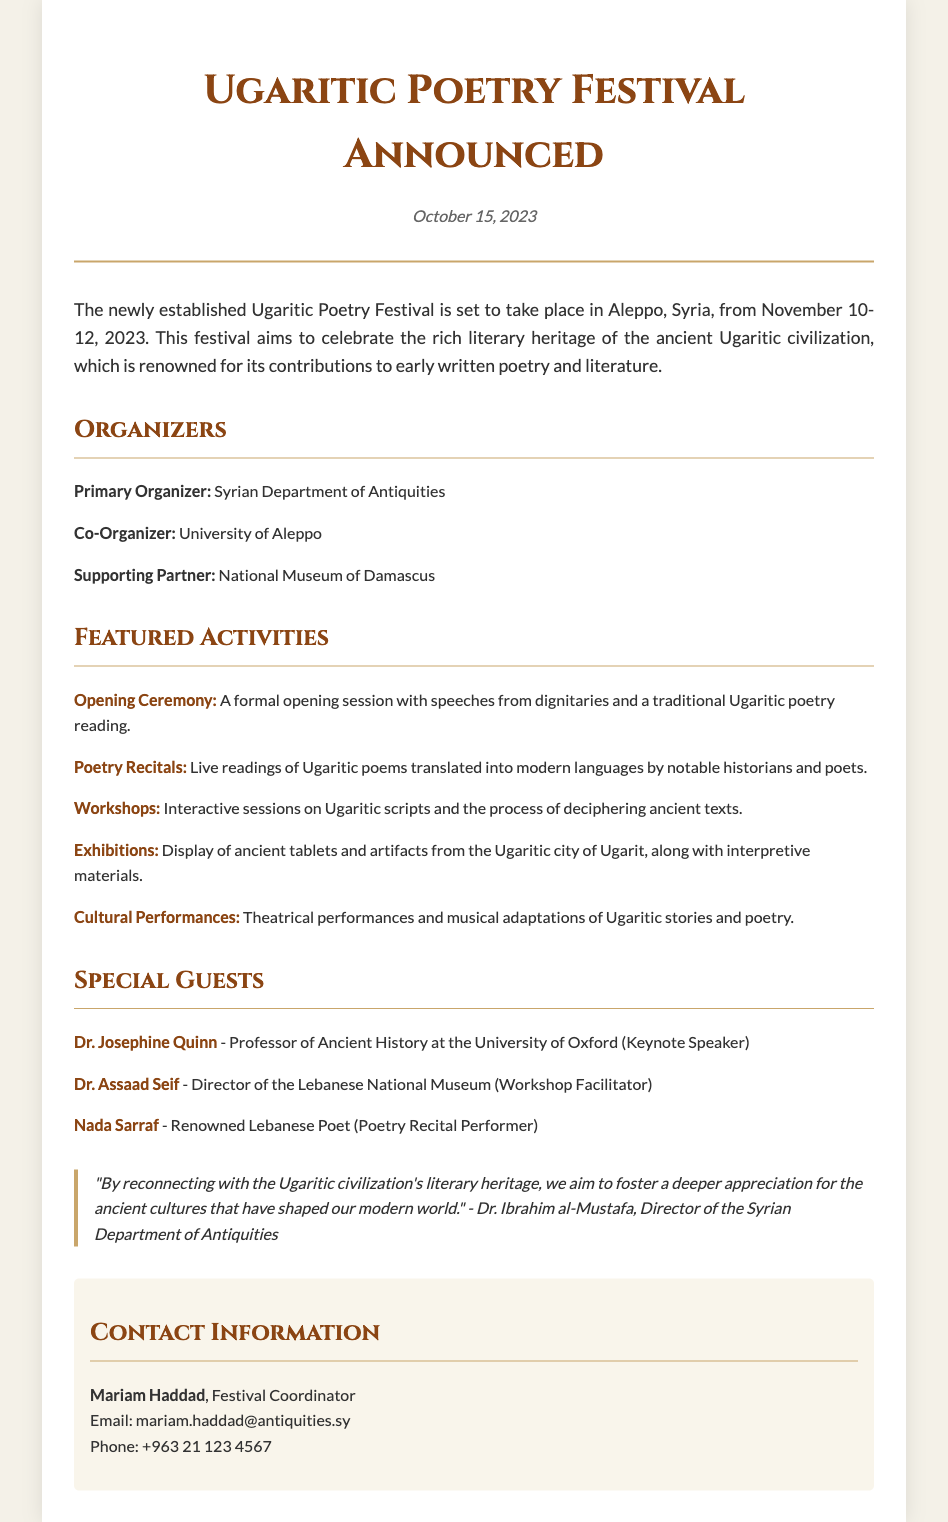What are the dates of the Ugaritic Poetry Festival? The festival will take place from November 10-12, 2023, as stated in the introduction.
Answer: November 10-12, 2023 Who is the primary organizer of the festival? The primary organizer listed in the document is the Syrian Department of Antiquities.
Answer: Syrian Department of Antiquities What type of activities will be featured at the festival? The document mentions that activities include Opening Ceremony, Poetry Recitals, Workshops, Exhibitions, and Cultural Performances.
Answer: Opening Ceremony, Poetry Recitals, Workshops, Exhibitions, Cultural Performances Who is the keynote speaker at the festival? The document specifies Dr. Josephine Quinn as the keynote speaker.
Answer: Dr. Josephine Quinn What is the purpose of the Ugaritic Poetry Festival? The festival aims to celebrate the rich literary heritage of the ancient Ugaritic civilization, as stated in the introduction.
Answer: Celebrate Ugaritic literary heritage What role does Dr. Assaad Seif have at the festival? According to the document, Dr. Assaad Seif will be a workshop facilitator.
Answer: Workshop Facilitator What quote is included from Dr. Ibrahim al-Mustafa? The document features a quote about reconnecting with the Ugaritic civilization's literary heritage.
Answer: "By reconnecting with the Ugaritic civilization's literary heritage..." How can one contact the festival coordinator? The contact information for the festival coordinator, Mariam Haddad, is provided, including email and phone number.
Answer: mariam.haddad@antiquities.sy, +963 21 123 4567 